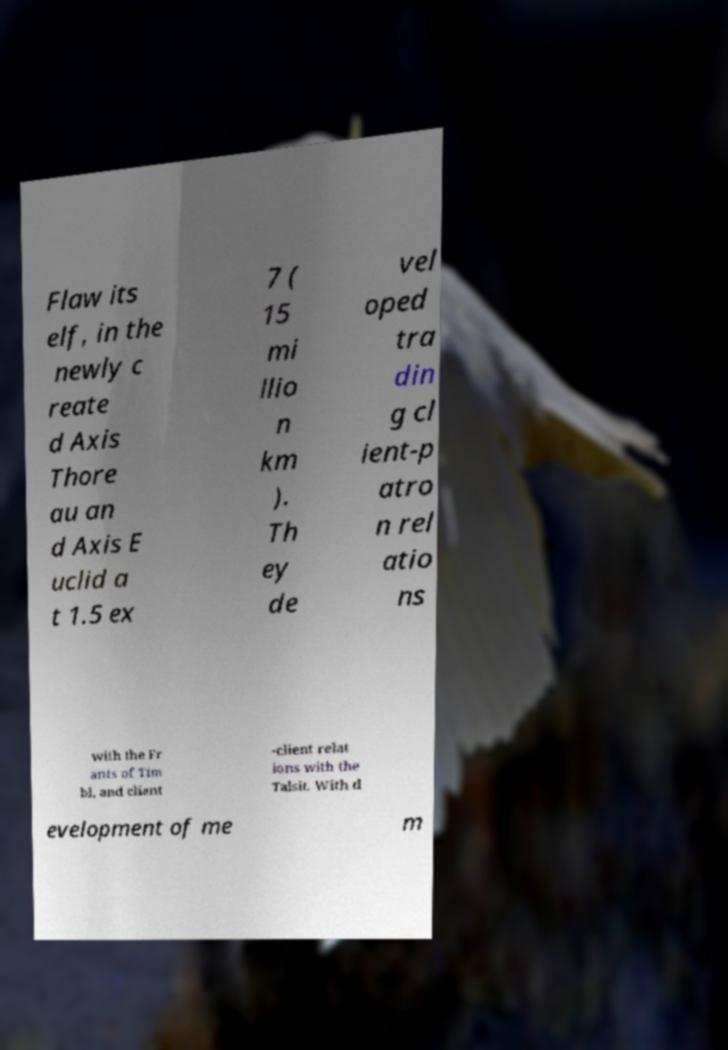For documentation purposes, I need the text within this image transcribed. Could you provide that? Flaw its elf, in the newly c reate d Axis Thore au an d Axis E uclid a t 1.5 ex 7 ( 15 mi llio n km ). Th ey de vel oped tra din g cl ient-p atro n rel atio ns with the Fr ants of Tim bl, and client -client relat ions with the Talsit. With d evelopment of me m 